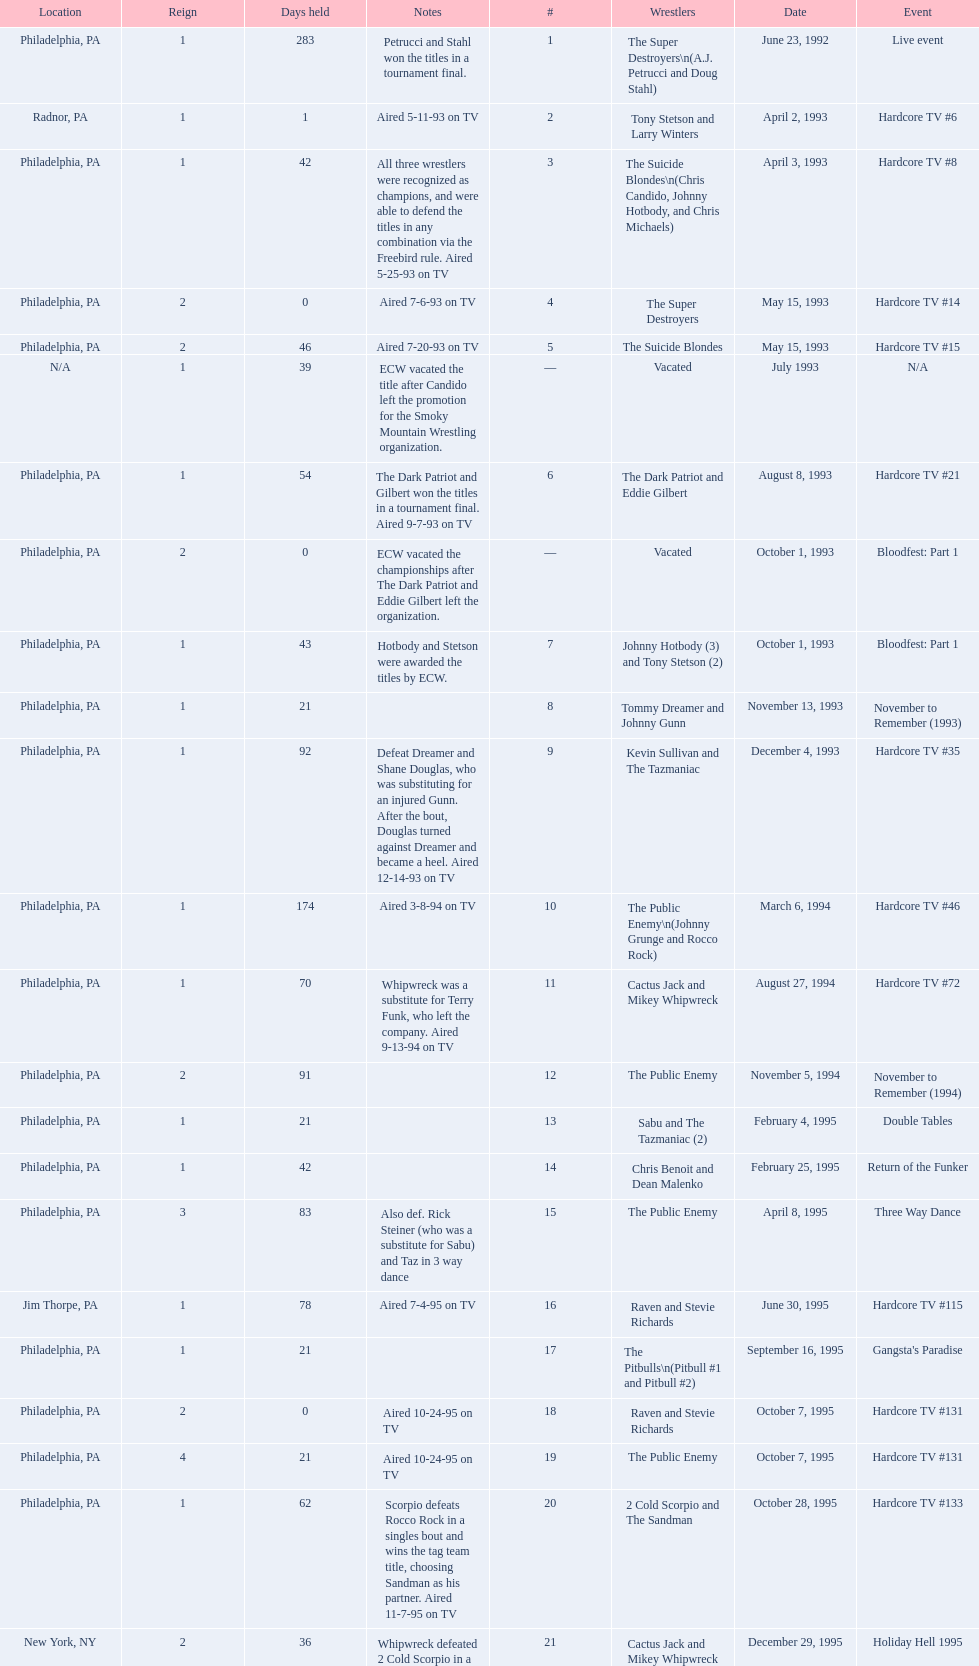What event comes before hardcore tv #14? Hardcore TV #8. Would you be able to parse every entry in this table? {'header': ['Location', 'Reign', 'Days held', 'Notes', '#', 'Wrestlers', 'Date', 'Event'], 'rows': [['Philadelphia, PA', '1', '283', 'Petrucci and Stahl won the titles in a tournament final.', '1', 'The Super Destroyers\\n(A.J. Petrucci and Doug Stahl)', 'June 23, 1992', 'Live event'], ['Radnor, PA', '1', '1', 'Aired 5-11-93 on TV', '2', 'Tony Stetson and Larry Winters', 'April 2, 1993', 'Hardcore TV #6'], ['Philadelphia, PA', '1', '42', 'All three wrestlers were recognized as champions, and were able to defend the titles in any combination via the Freebird rule. Aired 5-25-93 on TV', '3', 'The Suicide Blondes\\n(Chris Candido, Johnny Hotbody, and Chris Michaels)', 'April 3, 1993', 'Hardcore TV #8'], ['Philadelphia, PA', '2', '0', 'Aired 7-6-93 on TV', '4', 'The Super Destroyers', 'May 15, 1993', 'Hardcore TV #14'], ['Philadelphia, PA', '2', '46', 'Aired 7-20-93 on TV', '5', 'The Suicide Blondes', 'May 15, 1993', 'Hardcore TV #15'], ['N/A', '1', '39', 'ECW vacated the title after Candido left the promotion for the Smoky Mountain Wrestling organization.', '—', 'Vacated', 'July 1993', 'N/A'], ['Philadelphia, PA', '1', '54', 'The Dark Patriot and Gilbert won the titles in a tournament final. Aired 9-7-93 on TV', '6', 'The Dark Patriot and Eddie Gilbert', 'August 8, 1993', 'Hardcore TV #21'], ['Philadelphia, PA', '2', '0', 'ECW vacated the championships after The Dark Patriot and Eddie Gilbert left the organization.', '—', 'Vacated', 'October 1, 1993', 'Bloodfest: Part 1'], ['Philadelphia, PA', '1', '43', 'Hotbody and Stetson were awarded the titles by ECW.', '7', 'Johnny Hotbody (3) and Tony Stetson (2)', 'October 1, 1993', 'Bloodfest: Part 1'], ['Philadelphia, PA', '1', '21', '', '8', 'Tommy Dreamer and Johnny Gunn', 'November 13, 1993', 'November to Remember (1993)'], ['Philadelphia, PA', '1', '92', 'Defeat Dreamer and Shane Douglas, who was substituting for an injured Gunn. After the bout, Douglas turned against Dreamer and became a heel. Aired 12-14-93 on TV', '9', 'Kevin Sullivan and The Tazmaniac', 'December 4, 1993', 'Hardcore TV #35'], ['Philadelphia, PA', '1', '174', 'Aired 3-8-94 on TV', '10', 'The Public Enemy\\n(Johnny Grunge and Rocco Rock)', 'March 6, 1994', 'Hardcore TV #46'], ['Philadelphia, PA', '1', '70', 'Whipwreck was a substitute for Terry Funk, who left the company. Aired 9-13-94 on TV', '11', 'Cactus Jack and Mikey Whipwreck', 'August 27, 1994', 'Hardcore TV #72'], ['Philadelphia, PA', '2', '91', '', '12', 'The Public Enemy', 'November 5, 1994', 'November to Remember (1994)'], ['Philadelphia, PA', '1', '21', '', '13', 'Sabu and The Tazmaniac (2)', 'February 4, 1995', 'Double Tables'], ['Philadelphia, PA', '1', '42', '', '14', 'Chris Benoit and Dean Malenko', 'February 25, 1995', 'Return of the Funker'], ['Philadelphia, PA', '3', '83', 'Also def. Rick Steiner (who was a substitute for Sabu) and Taz in 3 way dance', '15', 'The Public Enemy', 'April 8, 1995', 'Three Way Dance'], ['Jim Thorpe, PA', '1', '78', 'Aired 7-4-95 on TV', '16', 'Raven and Stevie Richards', 'June 30, 1995', 'Hardcore TV #115'], ['Philadelphia, PA', '1', '21', '', '17', 'The Pitbulls\\n(Pitbull #1 and Pitbull #2)', 'September 16, 1995', "Gangsta's Paradise"], ['Philadelphia, PA', '2', '0', 'Aired 10-24-95 on TV', '18', 'Raven and Stevie Richards', 'October 7, 1995', 'Hardcore TV #131'], ['Philadelphia, PA', '4', '21', 'Aired 10-24-95 on TV', '19', 'The Public Enemy', 'October 7, 1995', 'Hardcore TV #131'], ['Philadelphia, PA', '1', '62', 'Scorpio defeats Rocco Rock in a singles bout and wins the tag team title, choosing Sandman as his partner. Aired 11-7-95 on TV', '20', '2 Cold Scorpio and The Sandman', 'October 28, 1995', 'Hardcore TV #133'], ['New York, NY', '2', '36', "Whipwreck defeated 2 Cold Scorpio in a singles match to win both the tag team titles and the ECW World Television Championship; Cactus Jack came out and declared himself to be Mikey's partner after he won the match.", '21', 'Cactus Jack and Mikey Whipwreck', 'December 29, 1995', 'Holiday Hell 1995'], ['New York, NY', '1', '182', '', '22', 'The Eliminators\\n(Kronus and Saturn)', 'February 3, 1996', 'Big Apple Blizzard Blast'], ['Philadelphia, PA', '1', '139', '', '23', 'The Gangstas\\n(Mustapha Saed and New Jack)', 'August 3, 1996', 'Doctor Is In'], ['Middletown, NY', '2', '85', 'Aired on 12/31/96 on Hardcore TV', '24', 'The Eliminators', 'December 20, 1996', 'Hardcore TV #193'], ['Philadelphia, PA', '1', '29', 'Aired 3/20/97 on Hardcore TV', '25', 'The Dudley Boyz\\n(Buh Buh Ray Dudley and D-Von Dudley)', 'March 15, 1997', 'Hostile City Showdown'], ['Philadelphia, PA', '3', '68', '', '26', 'The Eliminators', 'April 13, 1997', 'Barely Legal'], ['Waltham, MA', '2', '29', 'The Dudley Boyz defeated Kronus in a handicap match as a result of a sidelining injury sustained by Saturn. Aired 6-26-97 on TV', '27', 'The Dudley Boyz', 'June 20, 1997', 'Hardcore TV #218'], ['Philadelphia, PA', '2', '29', 'Aired 7-24-97 on TV', '28', 'The Gangstas', 'July 19, 1997', 'Heat Wave 1997/Hardcore TV #222'], ['Fort Lauderdale, FL', '3', '95', 'The Dudley Boyz won the championship via forfeit as a result of Mustapha Saed leaving the promotion before Hardcore Heaven took place.', '29', 'The Dudley Boyz', 'August 17, 1997', 'Hardcore Heaven (1997)'], ['Philadelphia, PA', '1', '28', 'Aired 9-27-97 on TV', '30', 'The Gangstanators\\n(Kronus (4) and New Jack (3))', 'September 20, 1997', 'As Good as it Gets'], ['Philadelphia, PA', '1', '48', 'Aired 11-1-97 on TV', '31', 'Full Blooded Italians\\n(Little Guido and Tracy Smothers)', 'October 18, 1997', 'Hardcore TV #236'], ['Waltham, MA', '1', '1', '', '32', 'Doug Furnas and Phil LaFon', 'December 5, 1997', 'Live event'], ['Philadelphia, PA', '1', '203', '', '33', 'Chris Candido (3) and Lance Storm', 'December 6, 1997', 'Better than Ever'], ['Philadelphia, PA', '1', '119', 'Aired 7-1-98 on TV', '34', 'Sabu (2) and Rob Van Dam', 'June 27, 1998', 'Hardcore TV #271'], ['Cleveland, OH', '4', '8', 'Aired 10-28-98 on TV', '35', 'The Dudley Boyz', 'October 24, 1998', 'Hardcore TV #288'], ['New Orleans, LA', '1', '5', '', '36', 'Balls Mahoney and Masato Tanaka', 'November 1, 1998', 'November to Remember (1998)'], ['New York, NY', '5', '37', 'Aired 11-11-98 on TV', '37', 'The Dudley Boyz', 'November 6, 1998', 'Hardcore TV #290'], ['Tokyo, Japan', '2', '125', 'Aired 12-16-98 on TV', '38', 'Sabu (3) and Rob Van Dam', 'December 13, 1998', 'ECW/FMW Supershow II'], ['Buffalo, NY', '6', '92', 'D-Von Dudley defeated Van Dam in a singles match to win the championship for his team. Aired 4-23-99 on TV', '39', 'The Dudley Boyz', 'April 17, 1999', 'Hardcore TV #313'], ['Dayton, OH', '1', '26', '', '40', 'Spike Dudley and Balls Mahoney (2)', 'July 18, 1999', 'Heat Wave (1999)'], ['Cleveland, OH', '7', '1', 'Aired 8-20-99 on TV', '41', 'The Dudley Boyz', 'August 13, 1999', 'Hardcore TV #330'], ['Toledo, OH', '2', '12', 'Aired 8-27-99 on TV', '42', 'Spike Dudley and Balls Mahoney (3)', 'August 14, 1999', 'Hardcore TV #331'], ['New York, NY', '8', '0', 'Aired 9-3-99 on TV', '43', 'The Dudley Boyz', 'August 26, 1999', 'ECW on TNN#2'], ['New York, NY', '1', '136', 'Aired 9-3-99 on TV', '44', 'Tommy Dreamer (2) and Raven (3)', 'August 26, 1999', 'ECW on TNN#2'], ['Birmingham, AL', '1', '48', '', '45', 'Impact Players\\n(Justin Credible and Lance Storm (2))', 'January 9, 2000', 'Guilty as Charged (2000)'], ['Cincinnati, OH', '1', '7', 'Aired 3-7-00 on TV', '46', 'Tommy Dreamer (3) and Masato Tanaka (2)', 'February 26, 2000', 'Hardcore TV #358'], ['Philadelphia, PA', '1', '8', 'Aired 3-10-00 on TV', '47', 'Mike Awesome and Raven (4)', 'March 4, 2000', 'ECW on TNN#29'], ['Danbury, CT', '2', '31', '', '48', 'Impact Players\\n(Justin Credible and Lance Storm (3))', 'March 12, 2000', 'Living Dangerously'], ['Philadelphia, PA', '3', '125', 'At CyberSlam, Justin Credible threw down the titles to become eligible for the ECW World Heavyweight Championship. Storm later left for World Championship Wrestling. As a result of the circumstances, Credible vacated the championship.', '—', 'Vacated', 'April 22, 2000', 'Live event'], ['New York, NY', '1', '1', 'Aired 9-1-00 on TV', '49', 'Yoshihiro Tajiri and Mikey Whipwreck (3)', 'August 25, 2000', 'ECW on TNN#55'], ['New York, NY', '1', '99', 'Aired 9-8-00 on TV', '50', 'Full Blooded Italians\\n(Little Guido (2) and Tony Mamaluke)', 'August 26, 2000', 'ECW on TNN#56'], ['New York, NY', '1', '122', "Doring and Roadkill's reign was the final one in the title's history.", '51', 'Danny Doring and Roadkill', 'December 3, 2000', 'Massacre on 34th Street']]} 